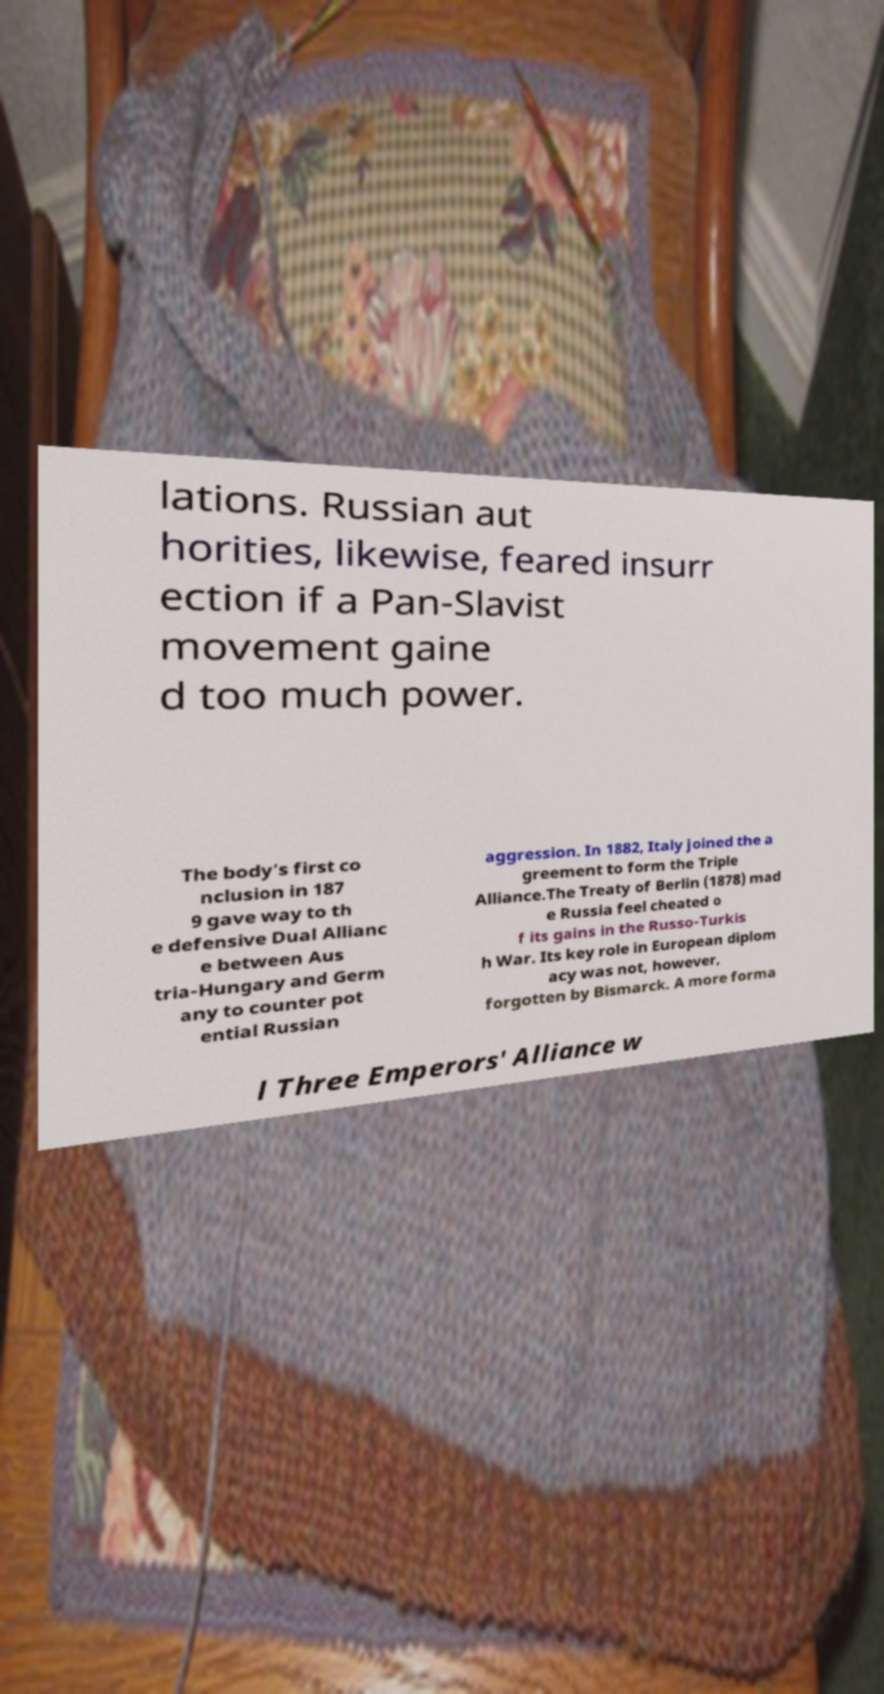Can you read and provide the text displayed in the image?This photo seems to have some interesting text. Can you extract and type it out for me? lations. Russian aut horities, likewise, feared insurr ection if a Pan-Slavist movement gaine d too much power. The body’s first co nclusion in 187 9 gave way to th e defensive Dual Allianc e between Aus tria-Hungary and Germ any to counter pot ential Russian aggression. In 1882, Italy joined the a greement to form the Triple Alliance.The Treaty of Berlin (1878) mad e Russia feel cheated o f its gains in the Russo-Turkis h War. Its key role in European diplom acy was not, however, forgotten by Bismarck. A more forma l Three Emperors' Alliance w 